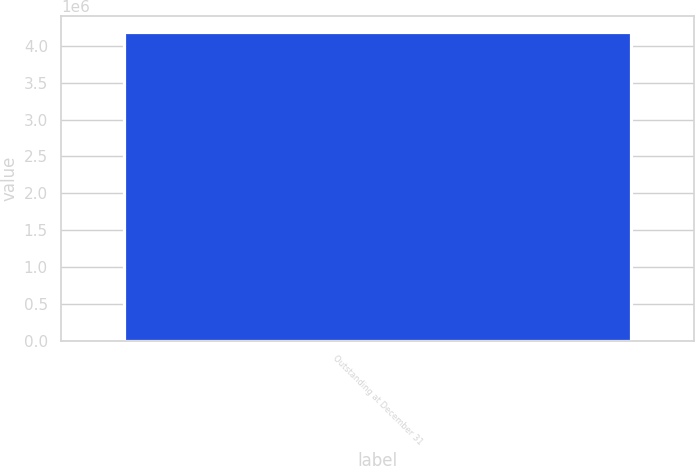Convert chart to OTSL. <chart><loc_0><loc_0><loc_500><loc_500><bar_chart><fcel>Outstanding at December 31<nl><fcel>4.19422e+06<nl></chart> 